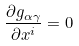Convert formula to latex. <formula><loc_0><loc_0><loc_500><loc_500>\frac { \partial g _ { \alpha \gamma } } { \partial x ^ { i } } = 0</formula> 